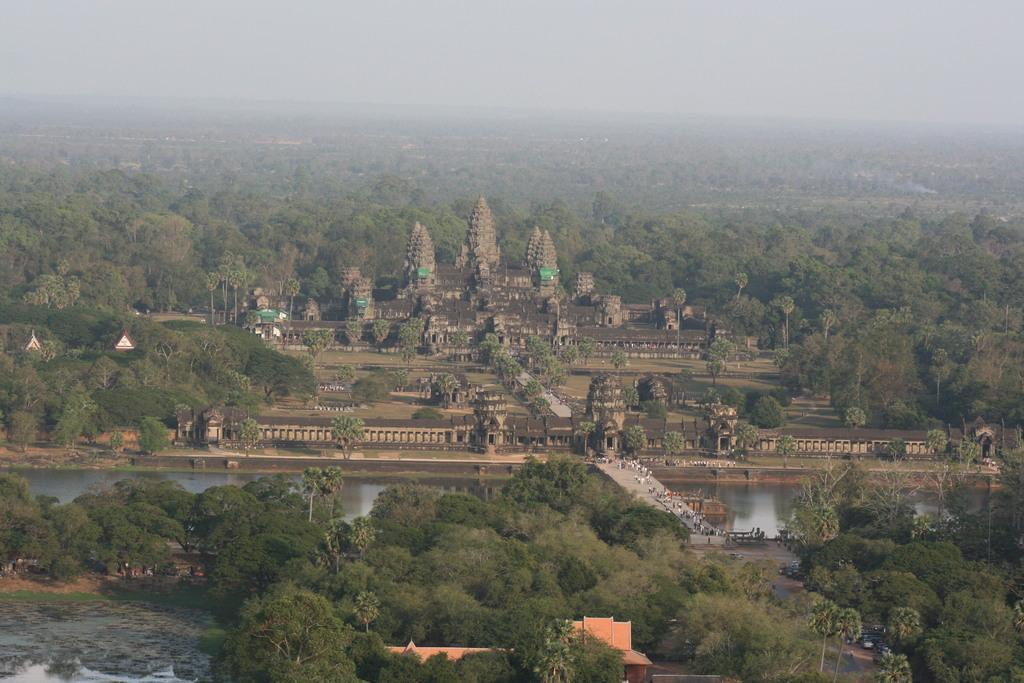Can you describe this image briefly? In the center of the image there is a fort. At the bottom we can see trees, persons and water. In the background there are trees and sky. 